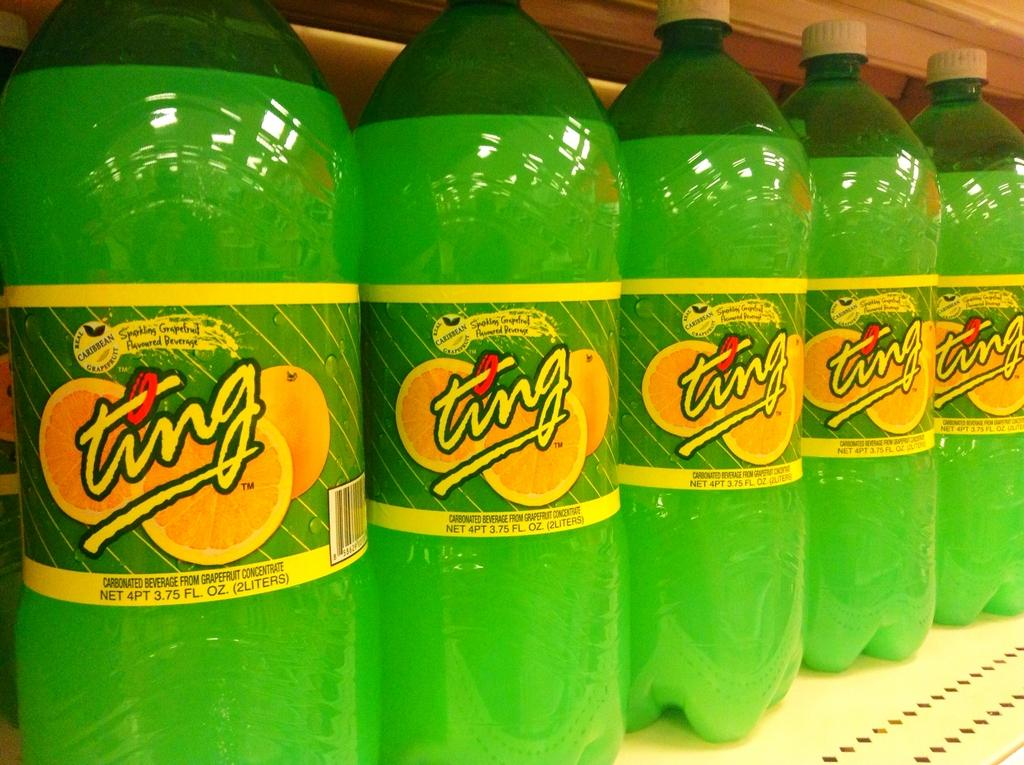<image>
Offer a succinct explanation of the picture presented. Many liters of Ting soda placed on a shelf. 